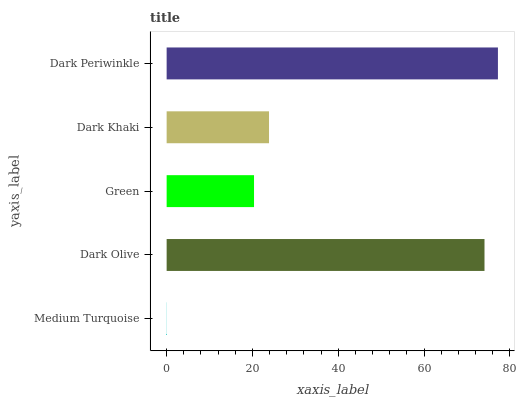Is Medium Turquoise the minimum?
Answer yes or no. Yes. Is Dark Periwinkle the maximum?
Answer yes or no. Yes. Is Dark Olive the minimum?
Answer yes or no. No. Is Dark Olive the maximum?
Answer yes or no. No. Is Dark Olive greater than Medium Turquoise?
Answer yes or no. Yes. Is Medium Turquoise less than Dark Olive?
Answer yes or no. Yes. Is Medium Turquoise greater than Dark Olive?
Answer yes or no. No. Is Dark Olive less than Medium Turquoise?
Answer yes or no. No. Is Dark Khaki the high median?
Answer yes or no. Yes. Is Dark Khaki the low median?
Answer yes or no. Yes. Is Dark Olive the high median?
Answer yes or no. No. Is Medium Turquoise the low median?
Answer yes or no. No. 